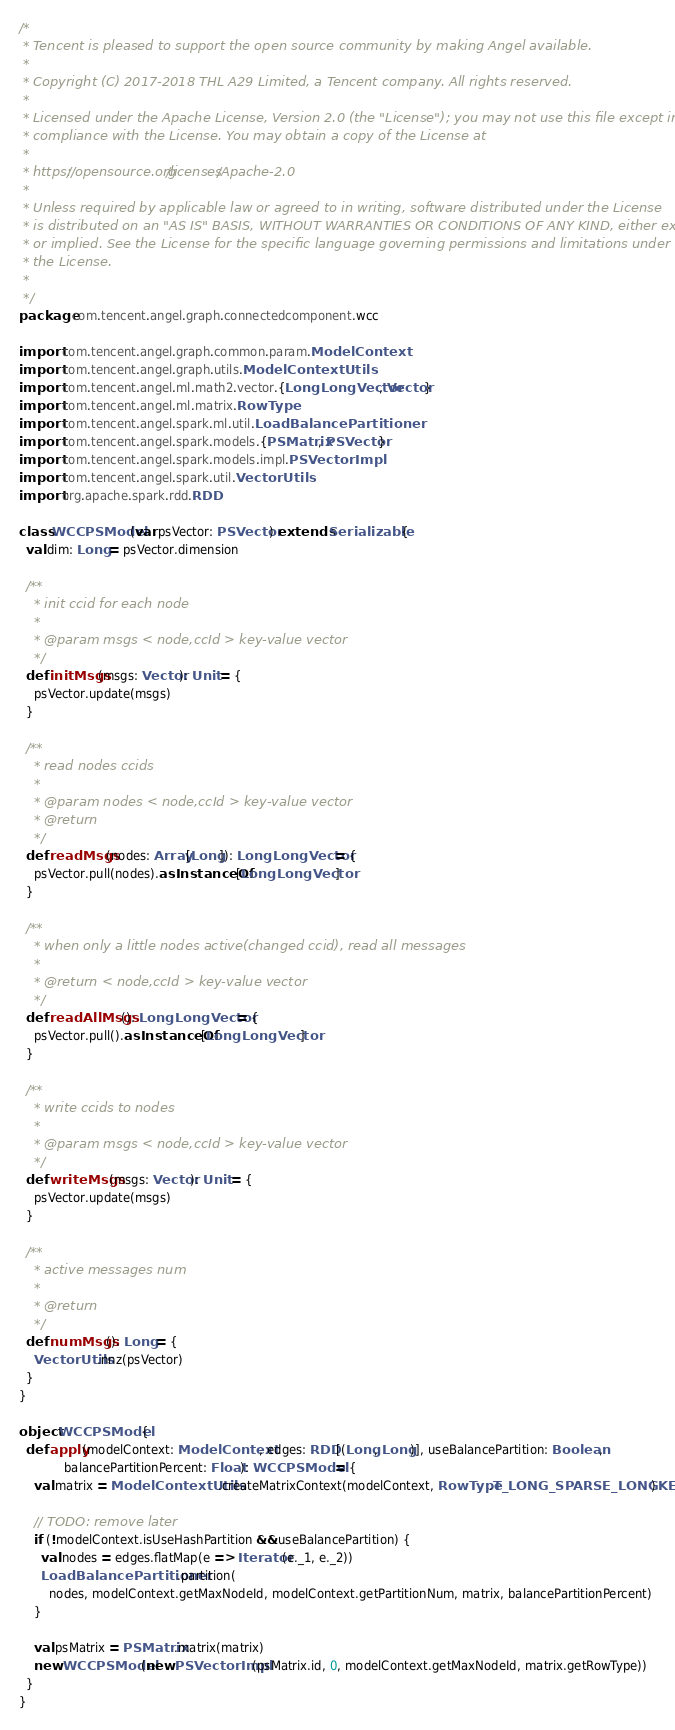<code> <loc_0><loc_0><loc_500><loc_500><_Scala_>/*
 * Tencent is pleased to support the open source community by making Angel available.
 *
 * Copyright (C) 2017-2018 THL A29 Limited, a Tencent company. All rights reserved.
 *
 * Licensed under the Apache License, Version 2.0 (the "License"); you may not use this file except in
 * compliance with the License. You may obtain a copy of the License at
 *
 * https://opensource.org/licenses/Apache-2.0
 *
 * Unless required by applicable law or agreed to in writing, software distributed under the License
 * is distributed on an "AS IS" BASIS, WITHOUT WARRANTIES OR CONDITIONS OF ANY KIND, either express
 * or implied. See the License for the specific language governing permissions and limitations under
 * the License.
 *
 */
package com.tencent.angel.graph.connectedcomponent.wcc

import com.tencent.angel.graph.common.param.ModelContext
import com.tencent.angel.graph.utils.ModelContextUtils
import com.tencent.angel.ml.math2.vector.{LongLongVector, Vector}
import com.tencent.angel.ml.matrix.RowType
import com.tencent.angel.spark.ml.util.LoadBalancePartitioner
import com.tencent.angel.spark.models.{PSMatrix, PSVector}
import com.tencent.angel.spark.models.impl.PSVectorImpl
import com.tencent.angel.spark.util.VectorUtils
import org.apache.spark.rdd.RDD

class WCCPSModel(var psVector: PSVector) extends Serializable {
  val dim: Long = psVector.dimension

  /**
    * init ccid for each node
    *
    * @param msgs < node,ccId > key-value vector
    */
  def initMsgs(msgs: Vector): Unit = {
    psVector.update(msgs)
  }

  /**
    * read nodes ccids
    *
    * @param nodes < node,ccId > key-value vector
    * @return
    */
  def readMsgs(nodes: Array[Long]): LongLongVector = {
    psVector.pull(nodes).asInstanceOf[LongLongVector]
  }

  /**
    * when only a little nodes active(changed ccid), read all messages
    *
    * @return < node,ccId > key-value vector
    */
  def readAllMsgs(): LongLongVector = {
    psVector.pull().asInstanceOf[LongLongVector]
  }

  /**
    * write ccids to nodes
    *
    * @param msgs < node,ccId > key-value vector
    */
  def writeMsgs(msgs: Vector): Unit = {
    psVector.update(msgs)
  }

  /**
    * active messages num
    *
    * @return
    */
  def numMsgs(): Long = {
    VectorUtils.nnz(psVector)
  }
}

object WCCPSModel {
  def apply(modelContext: ModelContext, edges: RDD[(Long, Long)], useBalancePartition: Boolean,
            balancePartitionPercent: Float): WCCPSModel = {
    val matrix = ModelContextUtils.createMatrixContext(modelContext, RowType.T_LONG_SPARSE_LONGKEY)
  
    // TODO: remove later
    if (!modelContext.isUseHashPartition && useBalancePartition) {
      val nodes = edges.flatMap(e => Iterator(e._1, e._2))
      LoadBalancePartitioner.partition(
        nodes, modelContext.getMaxNodeId, modelContext.getPartitionNum, matrix, balancePartitionPercent)
    }
  
    val psMatrix = PSMatrix.matrix(matrix)
    new WCCPSModel(new PSVectorImpl(psMatrix.id, 0, modelContext.getMaxNodeId, matrix.getRowType))
  }
}
</code> 